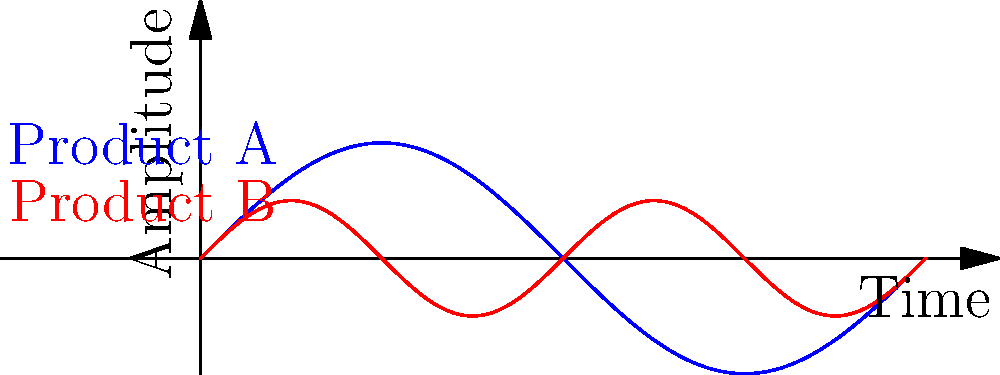In the graph above, two sine waves represent animation styles for different product interfaces. Product A uses $y = \sin(x)$, while Product B uses $y = 0.5\sin(2x)$. To create a unified animation style, you need to adjust Product B's function. Which modification to Product B's function would make its period match Product A's while maintaining half the amplitude? To solve this problem, let's follow these steps:

1. Analyze the given functions:
   Product A: $y = \sin(x)$
   Product B: $y = 0.5\sin(2x)$

2. Identify the differences:
   - Amplitude: Product A has amplitude 1, Product B has amplitude 0.5
   - Period: Product A has period $2\pi$, Product B has period $\pi$

3. To unify the animation style:
   - Keep Product B's amplitude at 0.5
   - Match Product B's period to Product A's (2π)

4. Recall the general sine function: $y = A\sin(Bx)$
   - A affects amplitude: $A = 0.5$ (keep as is)
   - B affects period: period = $\frac{2\pi}{B}$

5. To make Product B's period $2\pi$:
   $\frac{2\pi}{B} = 2\pi$
   $B = 1$

6. Therefore, the modified function for Product B should be:
   $y = 0.5\sin(x)$

This function maintains half the amplitude of Product A while matching its period.
Answer: $y = 0.5\sin(x)$ 